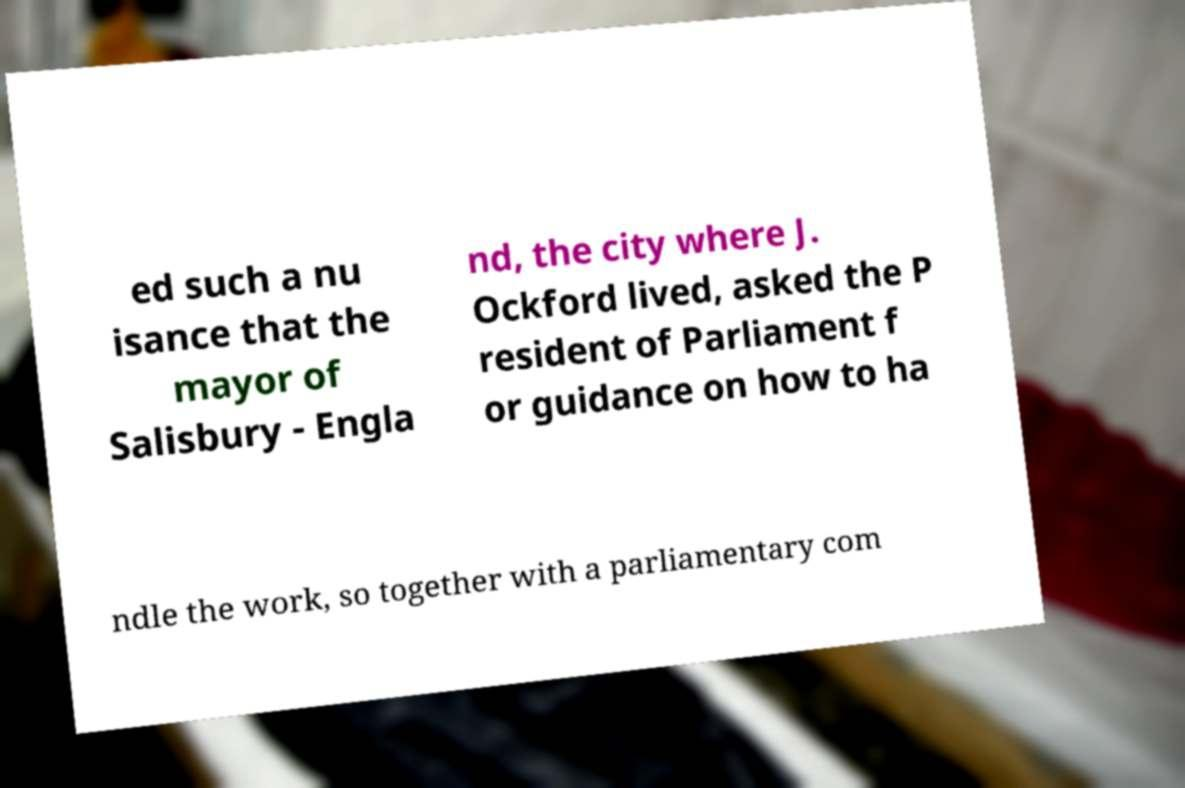What messages or text are displayed in this image? I need them in a readable, typed format. ed such a nu isance that the mayor of Salisbury - Engla nd, the city where J. Ockford lived, asked the P resident of Parliament f or guidance on how to ha ndle the work, so together with a parliamentary com 